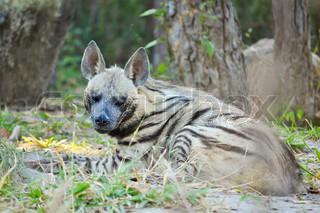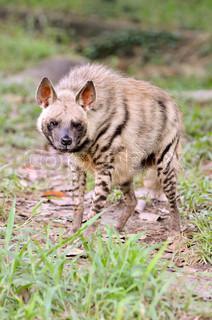The first image is the image on the left, the second image is the image on the right. Evaluate the accuracy of this statement regarding the images: "The right image contains at least two hyenas.". Is it true? Answer yes or no. No. The first image is the image on the left, the second image is the image on the right. For the images displayed, is the sentence "In the left image, we have a mother and her pups." factually correct? Answer yes or no. No. 